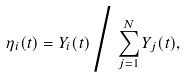Convert formula to latex. <formula><loc_0><loc_0><loc_500><loc_500>\eta _ { i } ( t ) = Y _ { i } ( t ) \Big / \sum _ { j = 1 } ^ { N } Y _ { j } ( t ) ,</formula> 